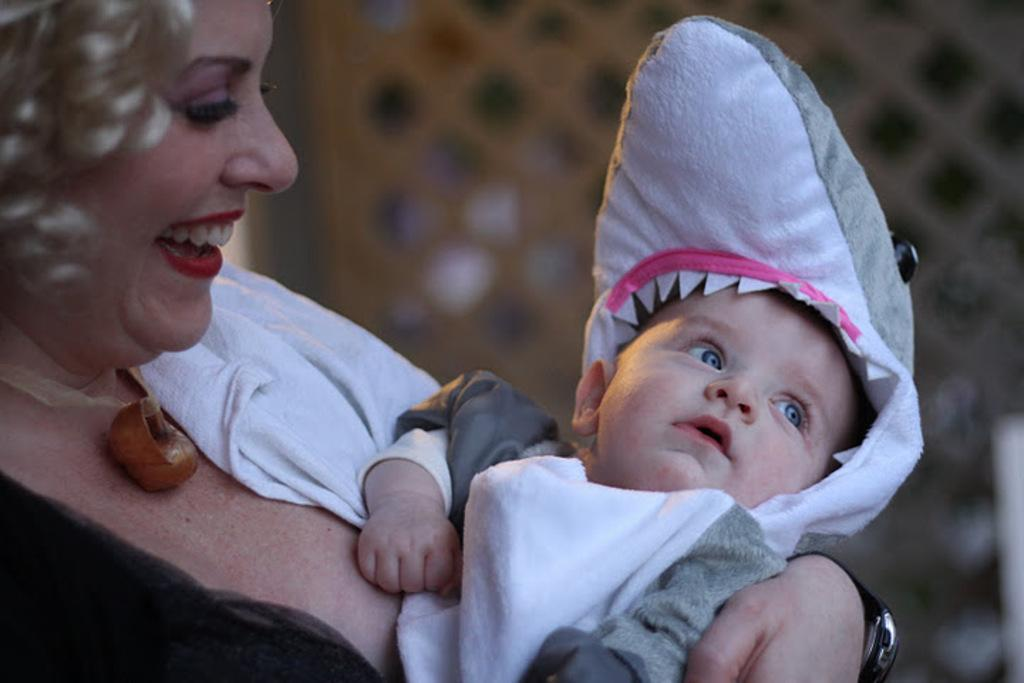How many people are in the image? There are persons in the image, but the exact number is not specified. What can be observed about the background of the image? The background of the image is blurred. Can you see a hen in the image? There is no hen present in the image. 